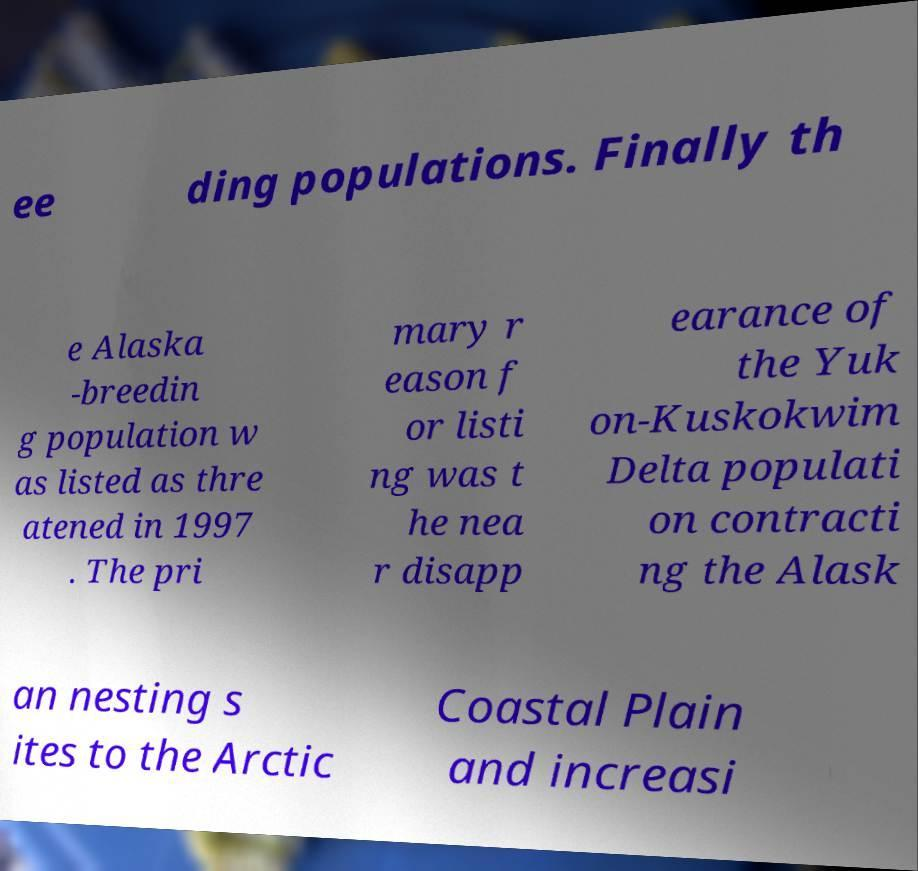Could you assist in decoding the text presented in this image and type it out clearly? ee ding populations. Finally th e Alaska -breedin g population w as listed as thre atened in 1997 . The pri mary r eason f or listi ng was t he nea r disapp earance of the Yuk on-Kuskokwim Delta populati on contracti ng the Alask an nesting s ites to the Arctic Coastal Plain and increasi 